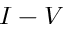<formula> <loc_0><loc_0><loc_500><loc_500>I - V</formula> 